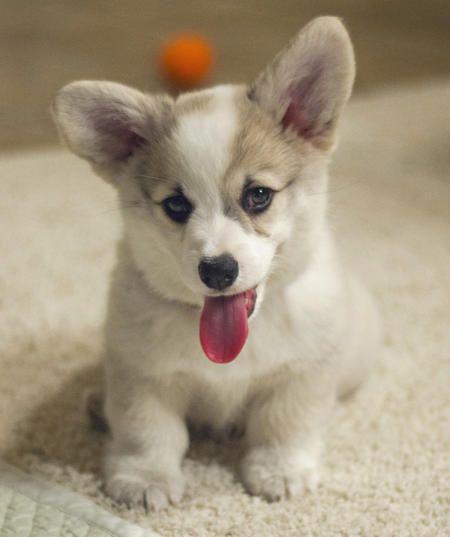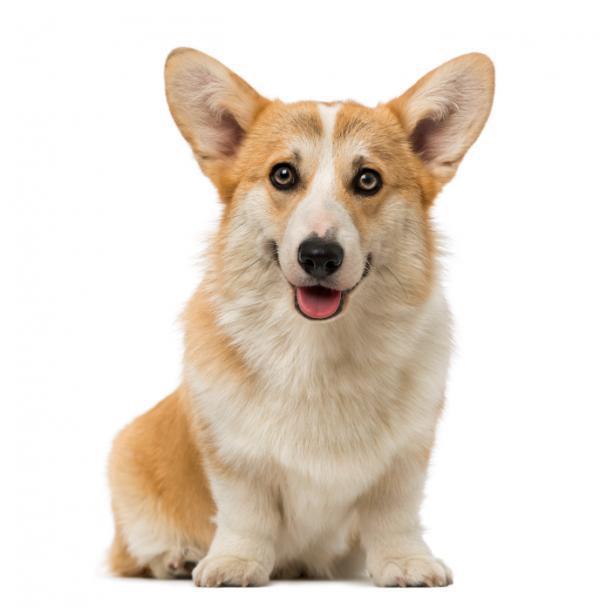The first image is the image on the left, the second image is the image on the right. Analyze the images presented: Is the assertion "There are exactly two dogs and both of them are outdoors." valid? Answer yes or no. No. The first image is the image on the left, the second image is the image on the right. Analyze the images presented: Is the assertion "All dogs are standing on all fours with their bodies aimed rightward, and at least one dog has its head turned to face the camera." valid? Answer yes or no. No. 